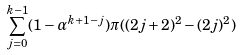<formula> <loc_0><loc_0><loc_500><loc_500>\sum _ { j = 0 } ^ { k - 1 } ( 1 - \alpha ^ { k + 1 - j } ) \pi ( ( 2 j + 2 ) ^ { 2 } - ( 2 j ) ^ { 2 } )</formula> 